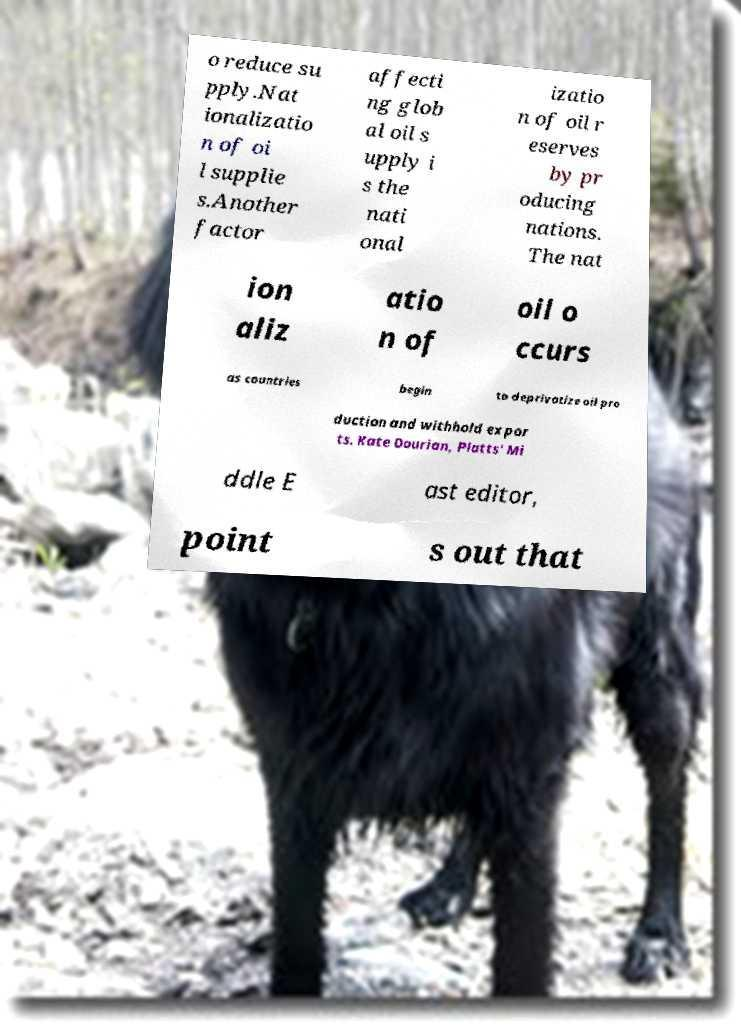Could you extract and type out the text from this image? o reduce su pply.Nat ionalizatio n of oi l supplie s.Another factor affecti ng glob al oil s upply i s the nati onal izatio n of oil r eserves by pr oducing nations. The nat ion aliz atio n of oil o ccurs as countries begin to deprivatize oil pro duction and withhold expor ts. Kate Dourian, Platts' Mi ddle E ast editor, point s out that 